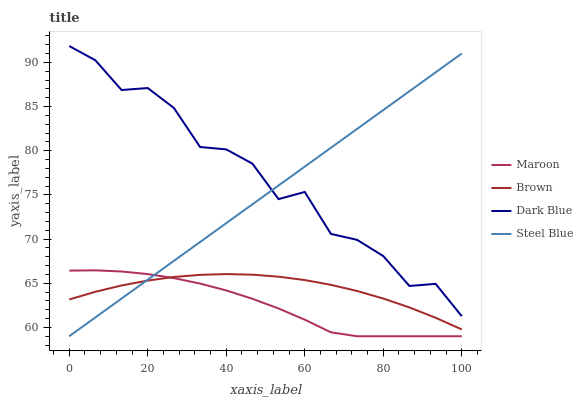Does Maroon have the minimum area under the curve?
Answer yes or no. Yes. Does Dark Blue have the maximum area under the curve?
Answer yes or no. Yes. Does Steel Blue have the minimum area under the curve?
Answer yes or no. No. Does Steel Blue have the maximum area under the curve?
Answer yes or no. No. Is Steel Blue the smoothest?
Answer yes or no. Yes. Is Dark Blue the roughest?
Answer yes or no. Yes. Is Maroon the smoothest?
Answer yes or no. No. Is Maroon the roughest?
Answer yes or no. No. Does Dark Blue have the lowest value?
Answer yes or no. No. Does Dark Blue have the highest value?
Answer yes or no. Yes. Does Steel Blue have the highest value?
Answer yes or no. No. Is Maroon less than Dark Blue?
Answer yes or no. Yes. Is Dark Blue greater than Brown?
Answer yes or no. Yes. Does Maroon intersect Steel Blue?
Answer yes or no. Yes. Is Maroon less than Steel Blue?
Answer yes or no. No. Is Maroon greater than Steel Blue?
Answer yes or no. No. Does Maroon intersect Dark Blue?
Answer yes or no. No. 